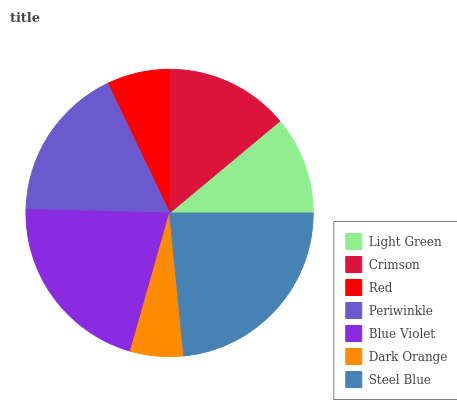Is Dark Orange the minimum?
Answer yes or no. Yes. Is Steel Blue the maximum?
Answer yes or no. Yes. Is Crimson the minimum?
Answer yes or no. No. Is Crimson the maximum?
Answer yes or no. No. Is Crimson greater than Light Green?
Answer yes or no. Yes. Is Light Green less than Crimson?
Answer yes or no. Yes. Is Light Green greater than Crimson?
Answer yes or no. No. Is Crimson less than Light Green?
Answer yes or no. No. Is Crimson the high median?
Answer yes or no. Yes. Is Crimson the low median?
Answer yes or no. Yes. Is Blue Violet the high median?
Answer yes or no. No. Is Blue Violet the low median?
Answer yes or no. No. 